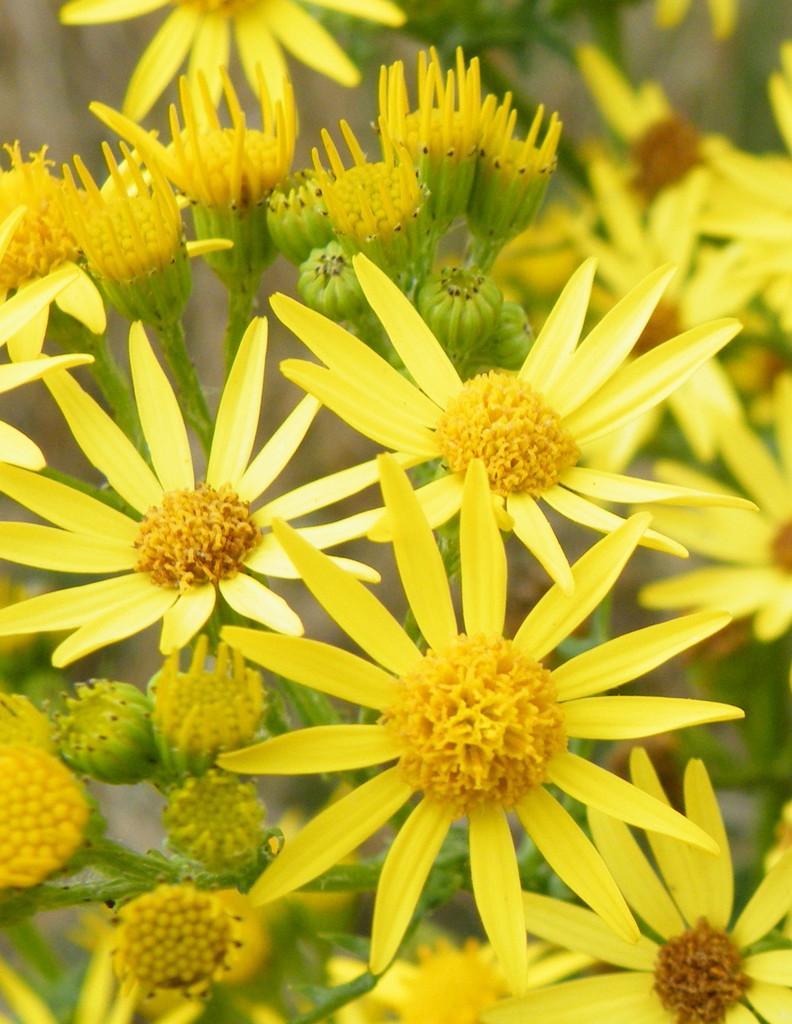Could you give a brief overview of what you see in this image? In the image we can see some flowers. 